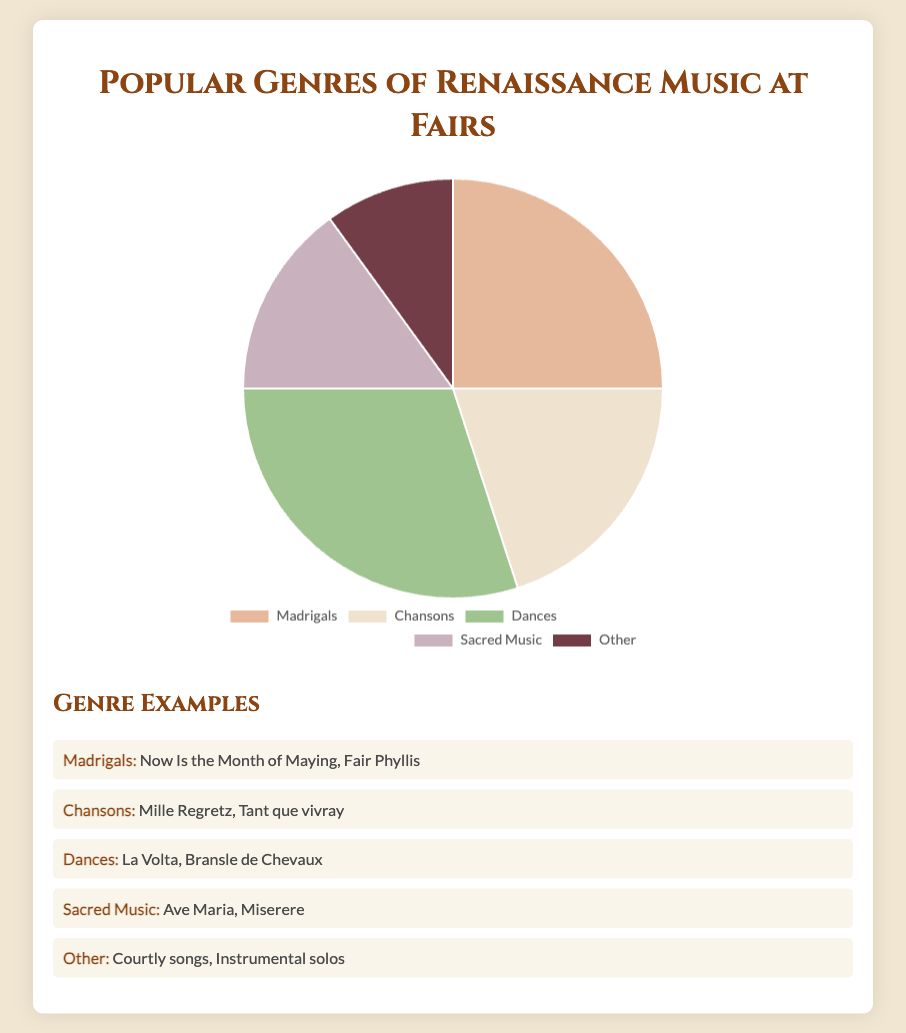What genre occupies the largest section of the pie chart? The largest section on the pie chart represents the genre 'Dances', which occupies 30% of the total.
Answer: Dances How does the percentage of Madrigals compare to the percentage of Sacred Music? The percentage of Madrigals is 25%, while the percentage of Sacred Music is 15%. Madrigals have a higher percentage compared to Sacred Music.
Answer: Madrigals What percentage of the pie chart is dedicated to Chansons and Other together? Adding the percentages for Chansons (20%) and Other (10%) gives a total of 30%.
Answer: 30% Is the percentage of Dances greater than the combined percentages of Madrigals and Other? Dances occupy 30% of the pie chart. The combined percentages of Madrigals (25%) and Other (10%) are 35%. Therefore, Dances percentage is not greater than the combined percentages of Madrigals and Other.
Answer: No Which genre occupies exactly one-quarter of the pie chart? Madrigals occupy 25% of the pie chart, which is exactly one-quarter.
Answer: Madrigals How much percentage more does Dances occupy compared to Sacred Music? Dances occupy 30% and Sacred Music occupies 15%. The difference is 30% - 15% = 15%.
Answer: 15% If Sacred Music and Other were combined, would their total percentage be more or less than Chansons? Sacred Music is 15% and Other is 10%, combined they are 25%. Chansons are 20%. Therefore, the combined percentage of Sacred Music and Other is greater than Chansons.
Answer: More In terms of visual representation, which genre is depicted with the darkest color segment? The 'Other' category is depicted with the darkest color segment.
Answer: Other What percentage would you get if you combined the two smallest genre percentages? The smallest genre percentages are Sacred Music (15%) and Other (10%). Combined, they make 25%.
Answer: 25% Is the percentage of Madrigals less than or equal to the combined percentage of Chansons and Sacred Music? Madrigals are 25%, Chansons are 20%, and Sacred Music is 15%. The combined percentage of Chansons and Sacred Music is 35%, which is greater than the percentage of Madrigals.
Answer: Yes 